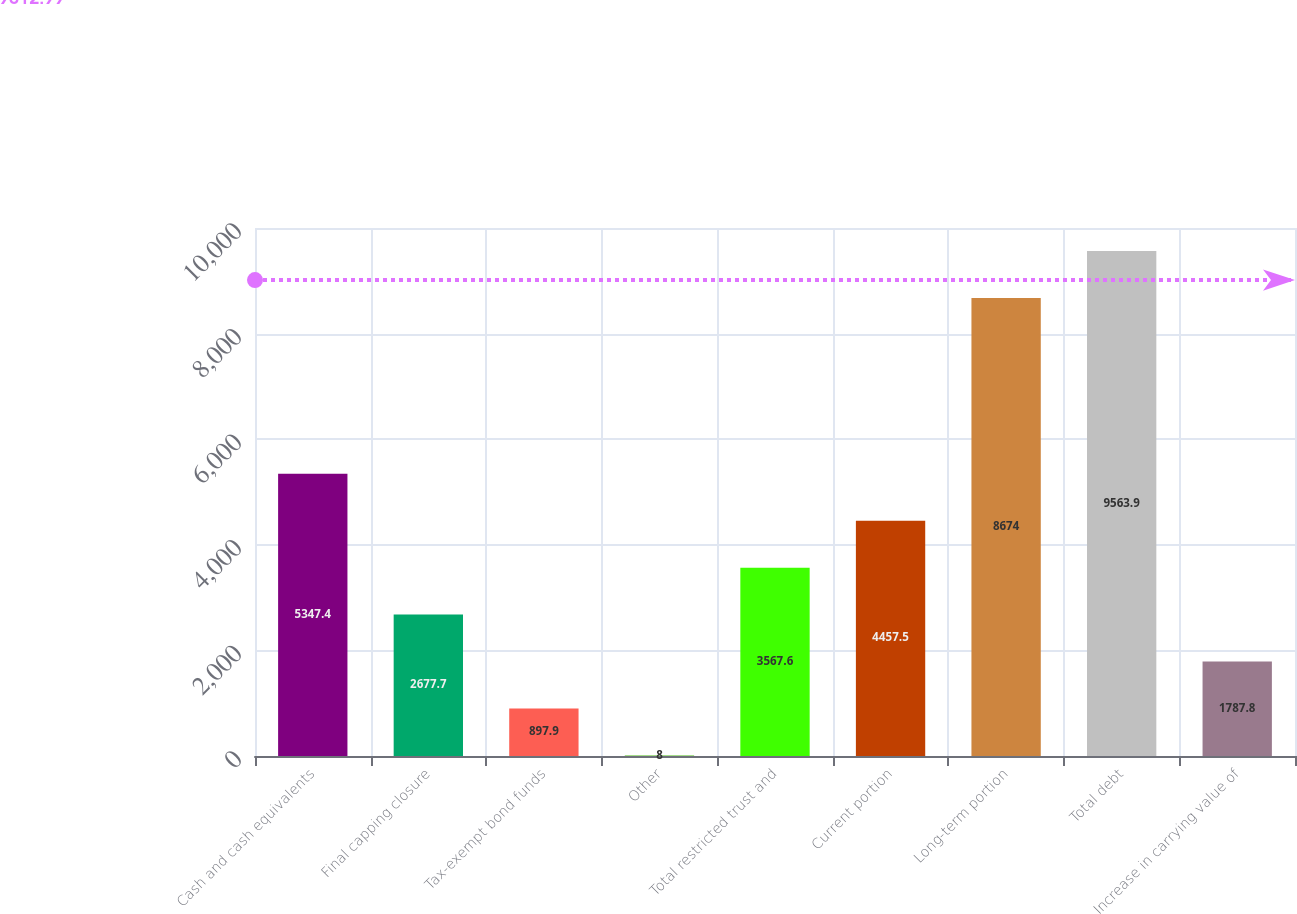Convert chart to OTSL. <chart><loc_0><loc_0><loc_500><loc_500><bar_chart><fcel>Cash and cash equivalents<fcel>Final capping closure<fcel>Tax-exempt bond funds<fcel>Other<fcel>Total restricted trust and<fcel>Current portion<fcel>Long-term portion<fcel>Total debt<fcel>Increase in carrying value of<nl><fcel>5347.4<fcel>2677.7<fcel>897.9<fcel>8<fcel>3567.6<fcel>4457.5<fcel>8674<fcel>9563.9<fcel>1787.8<nl></chart> 